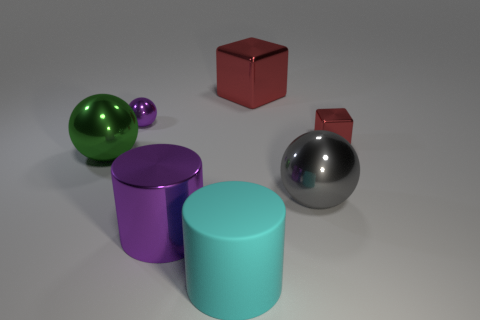What is the size of the object that is the same color as the small shiny sphere?
Offer a very short reply. Large. Are there fewer yellow metal cylinders than small purple metallic things?
Ensure brevity in your answer.  Yes. What material is the gray ball that is the same size as the cyan cylinder?
Ensure brevity in your answer.  Metal. There is a purple thing that is behind the small red shiny object; does it have the same size as the sphere that is to the right of the cyan matte thing?
Give a very brief answer. No. Is there a yellow ball made of the same material as the green sphere?
Offer a very short reply. No. What number of things are purple metal objects that are behind the big green thing or red cubes?
Ensure brevity in your answer.  3. Is the material of the cylinder that is behind the matte cylinder the same as the cyan cylinder?
Keep it short and to the point. No. Do the gray shiny thing and the tiny purple metallic object have the same shape?
Keep it short and to the point. Yes. How many red objects are to the left of the big sphere that is to the left of the large gray metallic thing?
Provide a short and direct response. 0. What material is the other big thing that is the same shape as the large cyan thing?
Provide a succinct answer. Metal. 